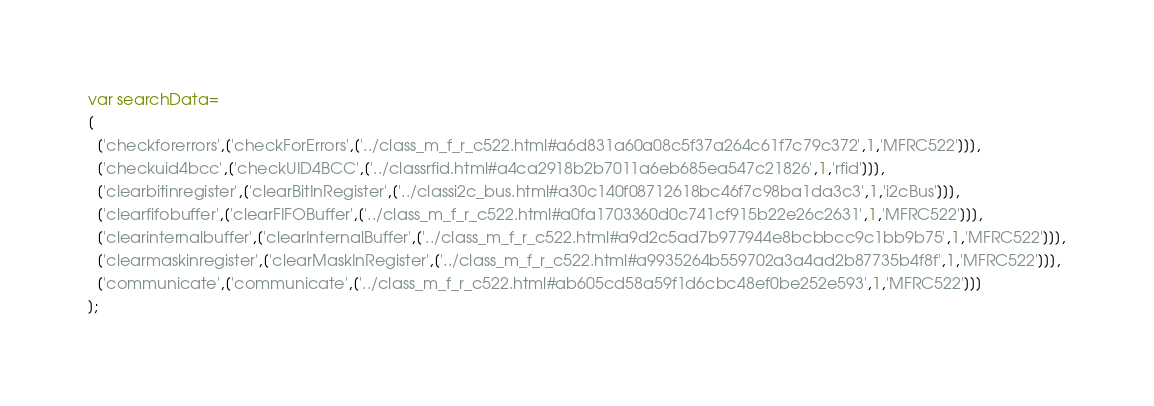Convert code to text. <code><loc_0><loc_0><loc_500><loc_500><_JavaScript_>var searchData=
[
  ['checkforerrors',['checkForErrors',['../class_m_f_r_c522.html#a6d831a60a08c5f37a264c61f7c79c372',1,'MFRC522']]],
  ['checkuid4bcc',['checkUID4BCC',['../classrfid.html#a4ca2918b2b7011a6eb685ea547c21826',1,'rfid']]],
  ['clearbitinregister',['clearBitInRegister',['../classi2c_bus.html#a30c140f08712618bc46f7c98ba1da3c3',1,'i2cBus']]],
  ['clearfifobuffer',['clearFIFOBuffer',['../class_m_f_r_c522.html#a0fa1703360d0c741cf915b22e26c2631',1,'MFRC522']]],
  ['clearinternalbuffer',['clearInternalBuffer',['../class_m_f_r_c522.html#a9d2c5ad7b977944e8bcbbcc9c1bb9b75',1,'MFRC522']]],
  ['clearmaskinregister',['clearMaskInRegister',['../class_m_f_r_c522.html#a9935264b559702a3a4ad2b87735b4f8f',1,'MFRC522']]],
  ['communicate',['communicate',['../class_m_f_r_c522.html#ab605cd58a59f1d6cbc48ef0be252e593',1,'MFRC522']]]
];
</code> 